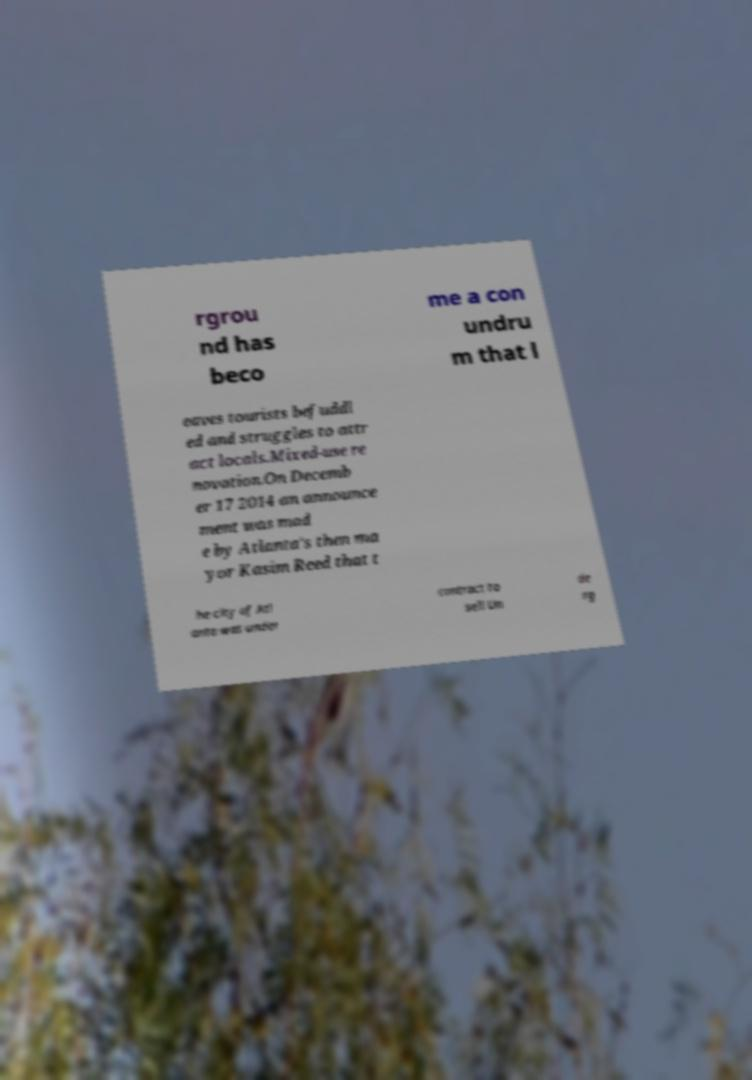Please identify and transcribe the text found in this image. rgrou nd has beco me a con undru m that l eaves tourists befuddl ed and struggles to attr act locals.Mixed-use re novation.On Decemb er 17 2014 an announce ment was mad e by Atlanta's then ma yor Kasim Reed that t he city of Atl anta was under contract to sell Un de rg 